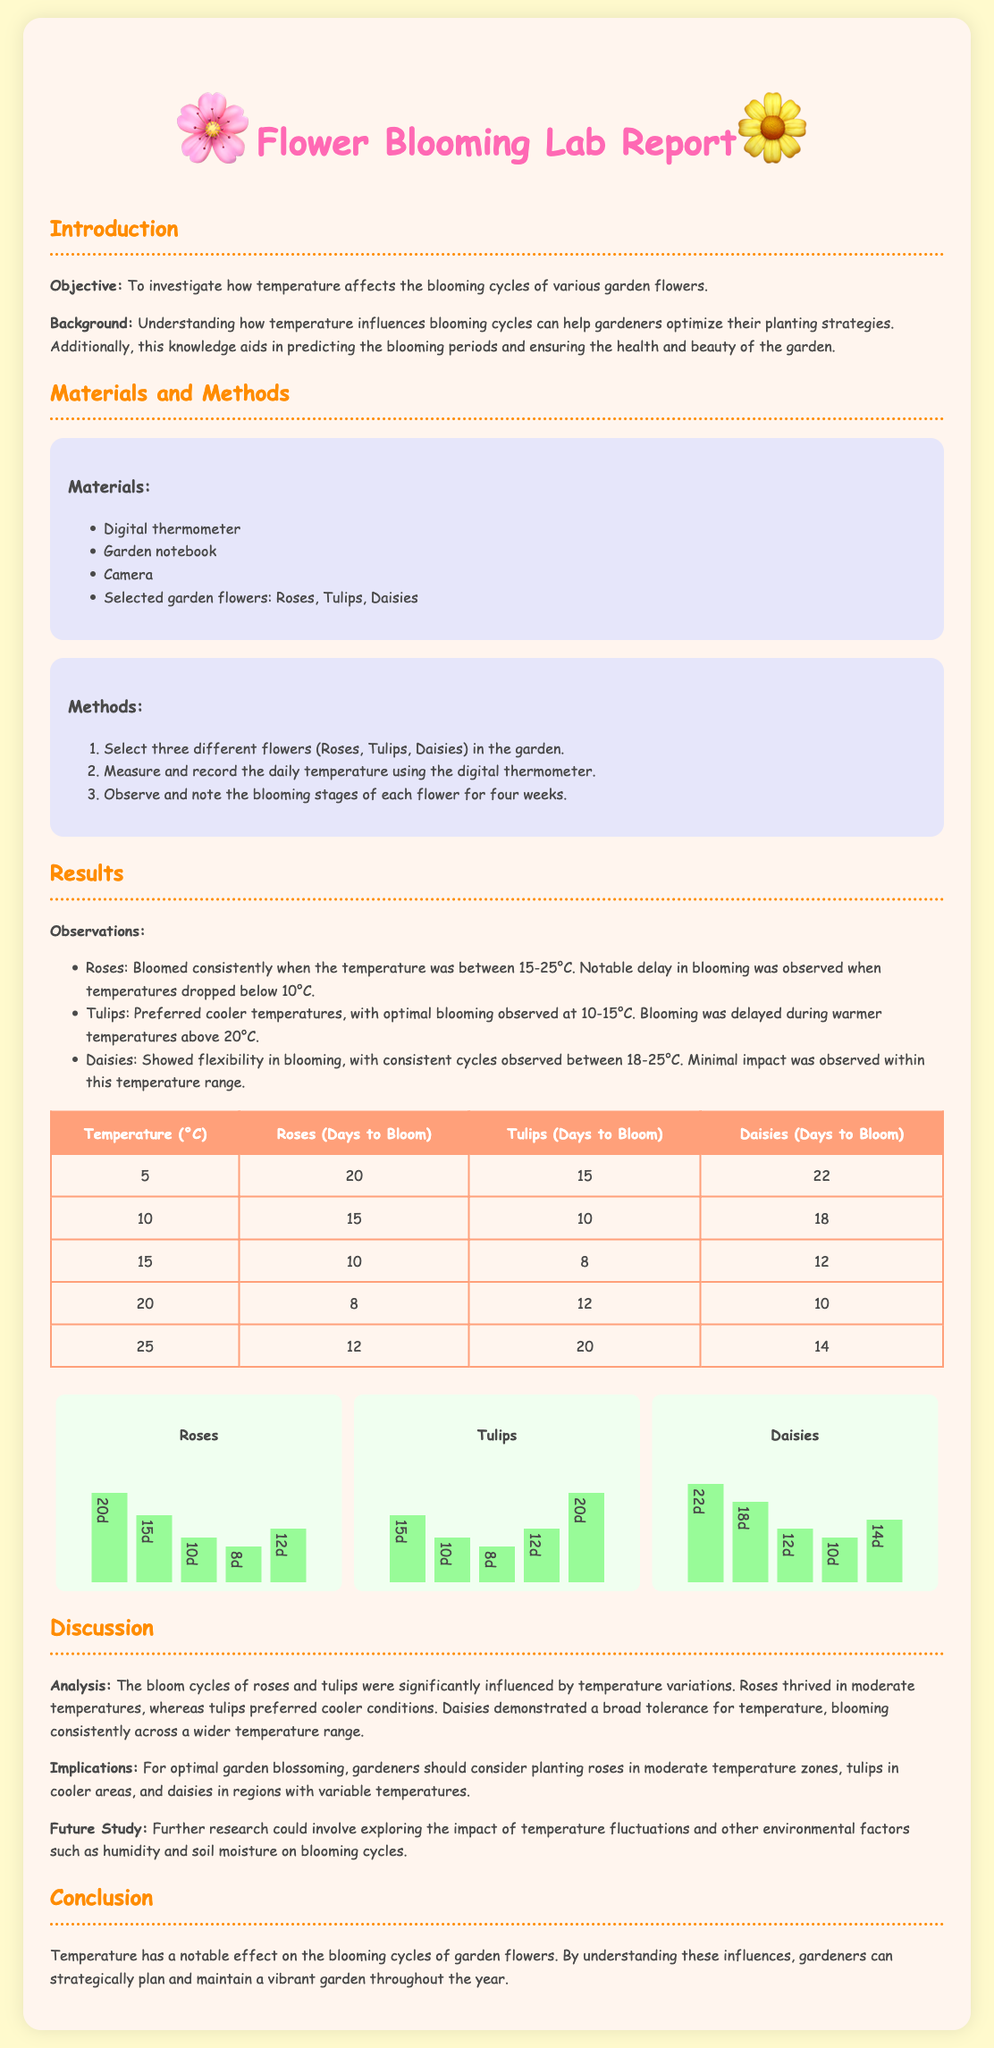What is the objective of the study? The objective is to investigate how temperature affects the blooming cycles of various garden flowers.
Answer: To investigate how temperature affects the blooming cycles What flowers were selected for the study? The document lists the selected flowers as Roses, Tulips, and Daisies.
Answer: Roses, Tulips, Daisies What was the optimal blooming temperature for Tulips? The optimal blooming for Tulips was observed at 10-15 degrees Celsius.
Answer: 10-15°C How many days does it take for Roses to bloom at 20°C? The document states that it takes 8 days for Roses to bloom at 20 degrees Celsius.
Answer: 8 days Which flower shows flexibility in blooming cycles? The document mentions that Daisies showed flexibility in blooming cycles.
Answer: Daisies At what temperature did Roses bloom consistently? Roses bloomed consistently when the temperature was between 15-25 degrees Celsius.
Answer: 15-25°C What is the main finding in the Discussion section? The main finding is that bloom cycles of roses and tulips were significantly influenced by temperature variations.
Answer: Bloom cycles of roses and tulips were significantly influenced by temperature variations What future study is suggested? Further research could explore the impact of temperature fluctuations and other environmental factors.
Answer: The impact of temperature fluctuations and other environmental factors 